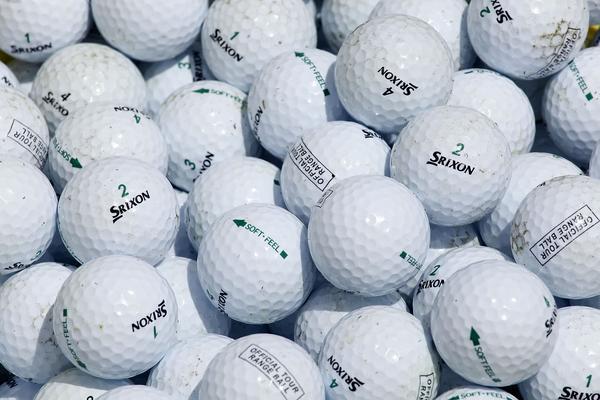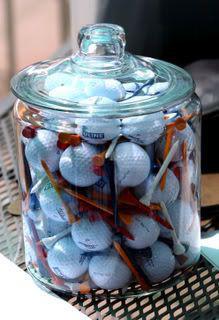The first image is the image on the left, the second image is the image on the right. Examine the images to the left and right. Is the description "A pile of used golf balls includes at least one pink and one yellow ball." accurate? Answer yes or no. No. The first image is the image on the left, the second image is the image on the right. Evaluate the accuracy of this statement regarding the images: "Some of the balls are in a clear container in one of the images.". Is it true? Answer yes or no. Yes. 